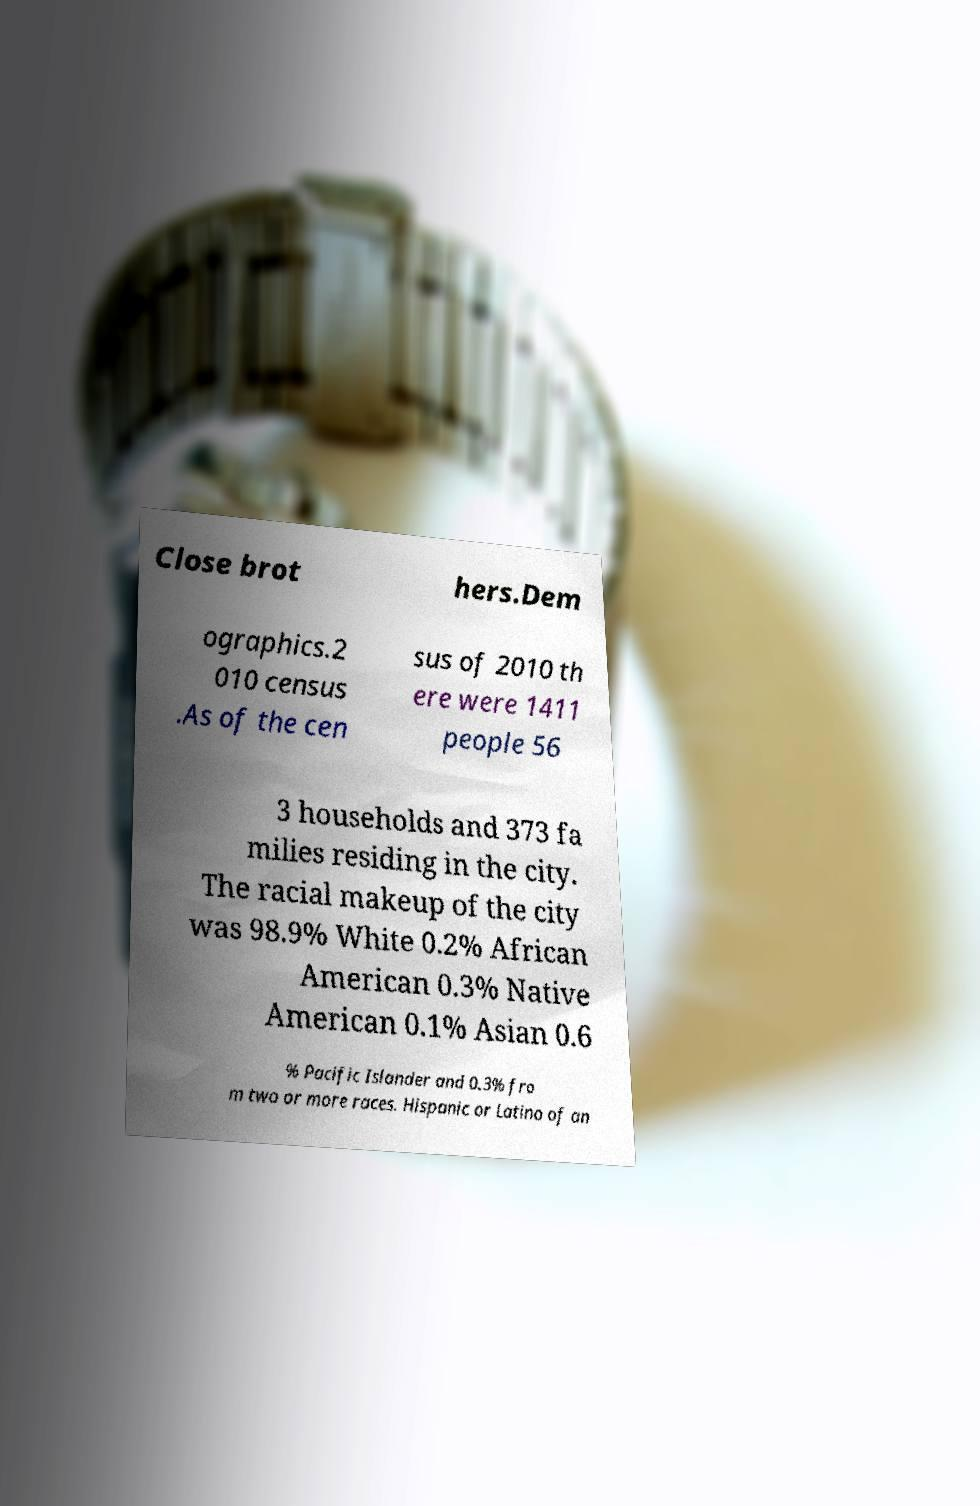There's text embedded in this image that I need extracted. Can you transcribe it verbatim? Close brot hers.Dem ographics.2 010 census .As of the cen sus of 2010 th ere were 1411 people 56 3 households and 373 fa milies residing in the city. The racial makeup of the city was 98.9% White 0.2% African American 0.3% Native American 0.1% Asian 0.6 % Pacific Islander and 0.3% fro m two or more races. Hispanic or Latino of an 